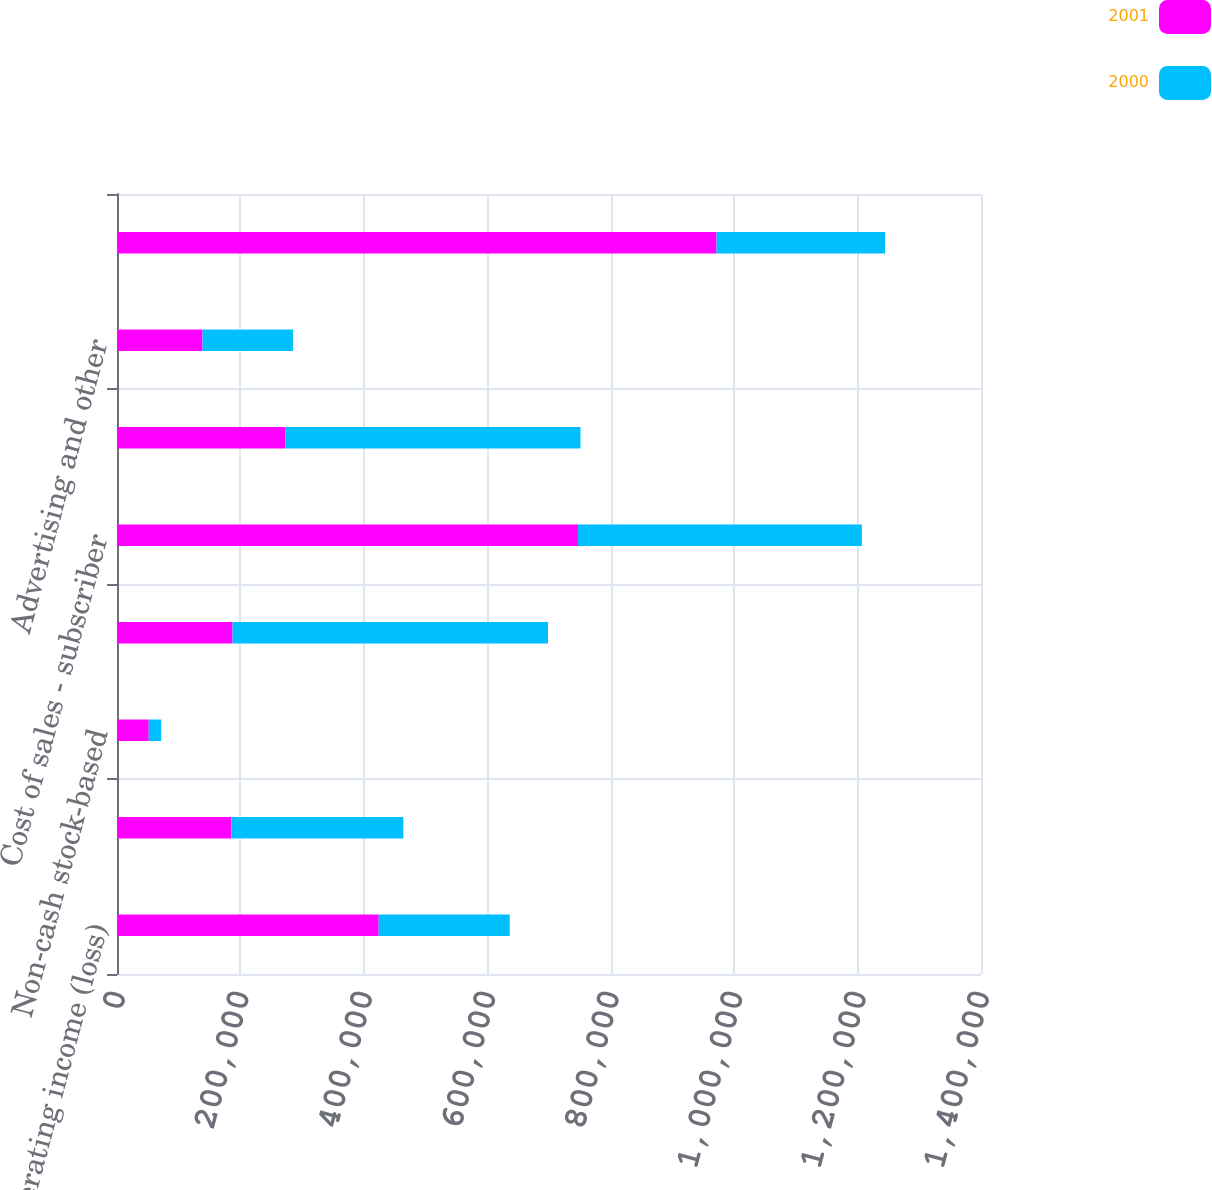<chart> <loc_0><loc_0><loc_500><loc_500><stacked_bar_chart><ecel><fcel>Operating income (loss)<fcel>Depreciation and amortization<fcel>Non-cash stock-based<fcel>EBITDA<fcel>Cost of sales - subscriber<fcel>Other subscriber promotion<fcel>Advertising and other<fcel>Pre-marketing cash flow<nl><fcel>2001<fcel>424066<fcel>185356<fcel>51465<fcel>187245<fcel>747020<fcel>273080<fcel>138540<fcel>971395<nl><fcel>2000<fcel>212302<fcel>278652<fcel>20173<fcel>511127<fcel>459909<fcel>477903<fcel>146563<fcel>273080<nl></chart> 